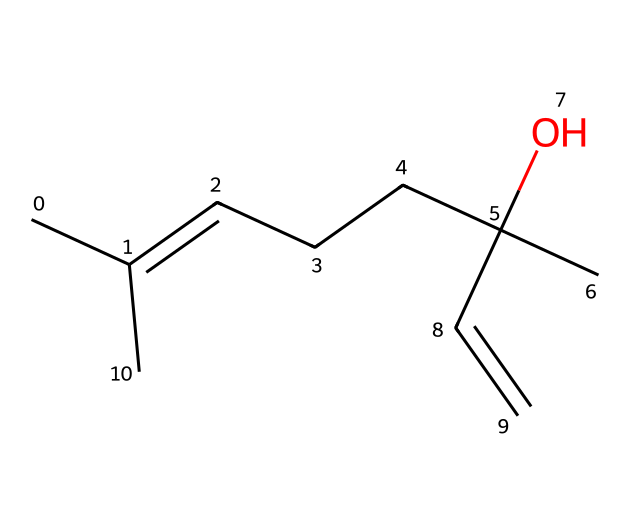What is the main functional group present in this chemical? The structure shows a hydroxyl group (-OH) that is characteristic of alcohols. This can be identified on the carbon chain where a carbon atom is bonded to a hydroxyl group.
Answer: alcohol How many carbon atoms are in this molecule? By analyzing the structure, we can count the number of carbon atoms connected in the carbon chain and branching. There are six carbon atoms in total visible in this specific SMILES representation.
Answer: 6 What type of bond is present in the chemical structure? The structure contains both single and double bonds, and the presence of the double bond is indicated between certain carbon atoms in the chain, which is typical in unsaturated hydrocarbons.
Answer: double bond What aspect of the chemical structure contributes to its calming aroma? The presence of the functional groups, especially the alcohol group, which is typically associated with pleasant aromas in flavors and fragrances, contributes to the calming effect of this lavender oil component.
Answer: alcohol group Is this compound aromatic or aliphatic? The structure is aliphatic as it consists of a straight or branched-chain of carbon atoms and does not include a benzene ring or similar structure that would classify it as aromatic.
Answer: aliphatic What is the molecular formula derived from the SMILES? From the provided SMILES, we can determine the molecular formula by counting the carbon (C), hydrogen (H), and oxygen (O) atoms. The count gives us a formula C8H14O, confirming the types of atoms present.
Answer: C8H14O What sensory characteristic does this chemical primarily influence? The chemical is primarily associated with a calming scent that can evoke relaxation, which is evident in its common use in aromatherapy and scented products, highlighting its influence on sensory perception.
Answer: calming scent 